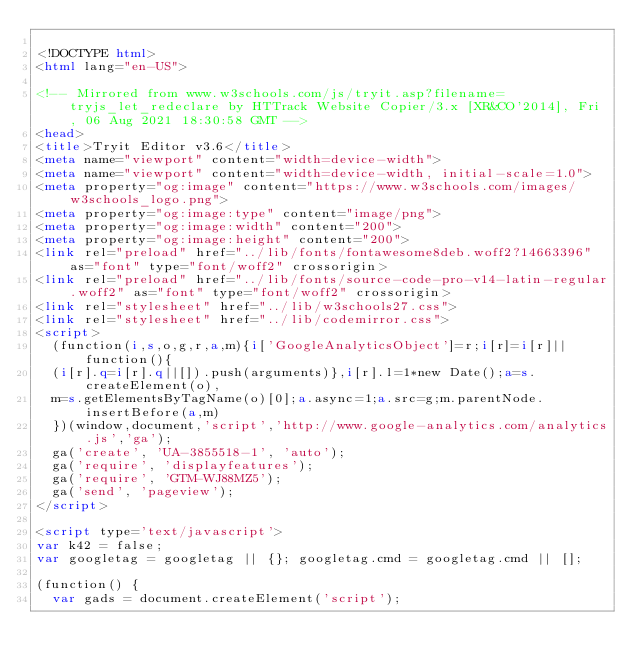<code> <loc_0><loc_0><loc_500><loc_500><_HTML_>
<!DOCTYPE html>
<html lang="en-US">

<!-- Mirrored from www.w3schools.com/js/tryit.asp?filename=tryjs_let_redeclare by HTTrack Website Copier/3.x [XR&CO'2014], Fri, 06 Aug 2021 18:30:58 GMT -->
<head>
<title>Tryit Editor v3.6</title>
<meta name="viewport" content="width=device-width">
<meta name="viewport" content="width=device-width, initial-scale=1.0">
<meta property="og:image" content="https://www.w3schools.com/images/w3schools_logo.png">
<meta property="og:image:type" content="image/png">
<meta property="og:image:width" content="200">
<meta property="og:image:height" content="200">
<link rel="preload" href="../lib/fonts/fontawesome8deb.woff2?14663396" as="font" type="font/woff2" crossorigin> 
<link rel="preload" href="../lib/fonts/source-code-pro-v14-latin-regular.woff2" as="font" type="font/woff2" crossorigin> 
<link rel="stylesheet" href="../lib/w3schools27.css">
<link rel="stylesheet" href="../lib/codemirror.css">
<script>
  (function(i,s,o,g,r,a,m){i['GoogleAnalyticsObject']=r;i[r]=i[r]||function(){
  (i[r].q=i[r].q||[]).push(arguments)},i[r].l=1*new Date();a=s.createElement(o),
  m=s.getElementsByTagName(o)[0];a.async=1;a.src=g;m.parentNode.insertBefore(a,m)
  })(window,document,'script','http://www.google-analytics.com/analytics.js','ga');
  ga('create', 'UA-3855518-1', 'auto');
  ga('require', 'displayfeatures');
  ga('require', 'GTM-WJ88MZ5');
  ga('send', 'pageview');
</script>

<script type='text/javascript'>
var k42 = false;
var googletag = googletag || {}; googletag.cmd = googletag.cmd || [];

(function() {
  var gads = document.createElement('script');</code> 